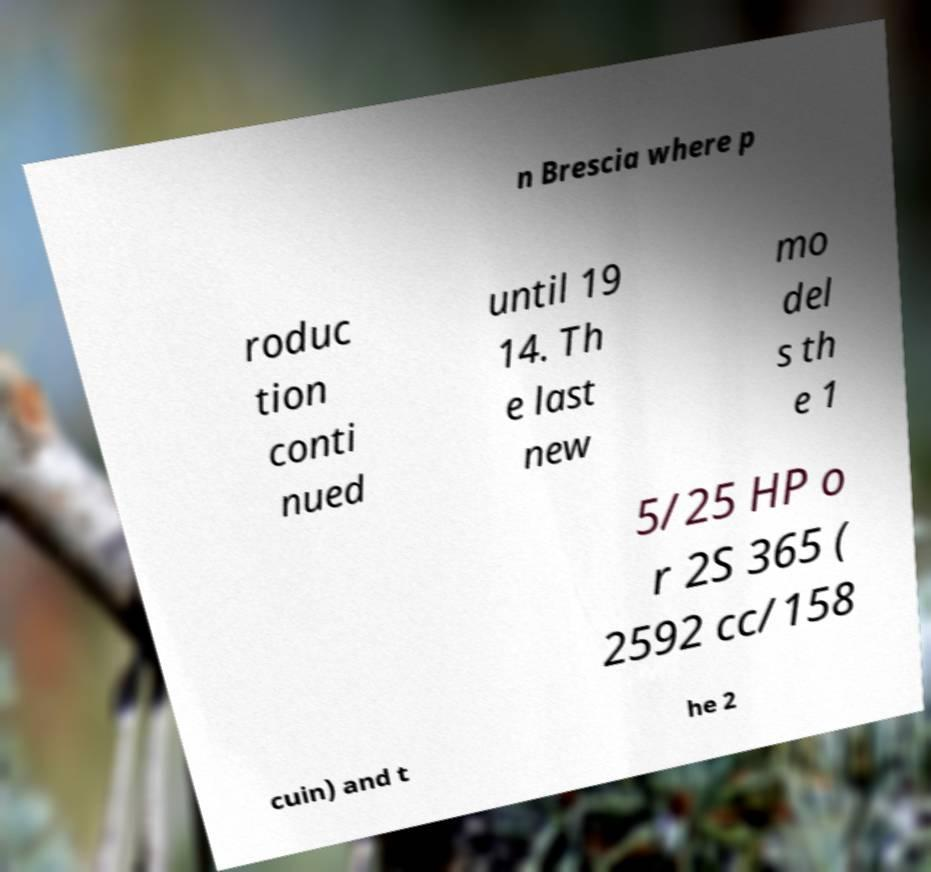There's text embedded in this image that I need extracted. Can you transcribe it verbatim? n Brescia where p roduc tion conti nued until 19 14. Th e last new mo del s th e 1 5/25 HP o r 2S 365 ( 2592 cc/158 cuin) and t he 2 